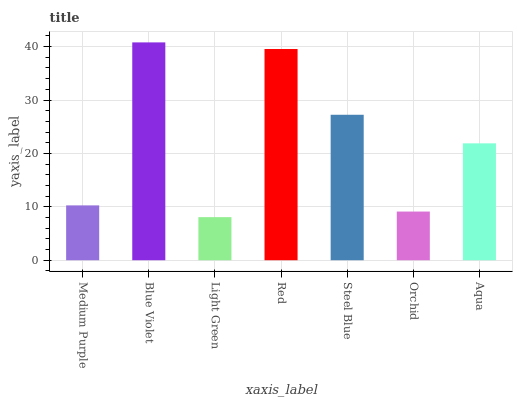Is Light Green the minimum?
Answer yes or no. Yes. Is Blue Violet the maximum?
Answer yes or no. Yes. Is Blue Violet the minimum?
Answer yes or no. No. Is Light Green the maximum?
Answer yes or no. No. Is Blue Violet greater than Light Green?
Answer yes or no. Yes. Is Light Green less than Blue Violet?
Answer yes or no. Yes. Is Light Green greater than Blue Violet?
Answer yes or no. No. Is Blue Violet less than Light Green?
Answer yes or no. No. Is Aqua the high median?
Answer yes or no. Yes. Is Aqua the low median?
Answer yes or no. Yes. Is Medium Purple the high median?
Answer yes or no. No. Is Light Green the low median?
Answer yes or no. No. 